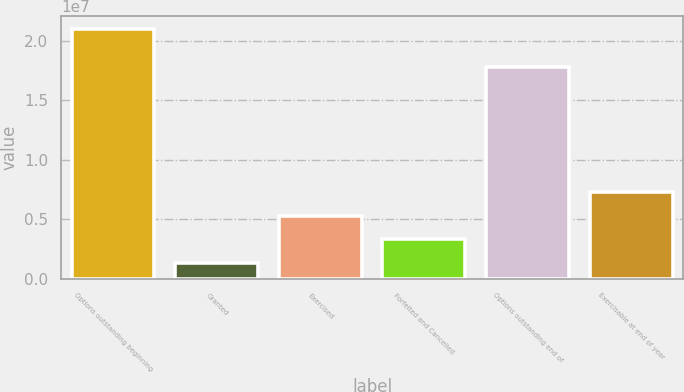<chart> <loc_0><loc_0><loc_500><loc_500><bar_chart><fcel>Options outstanding beginning<fcel>Granted<fcel>Exercised<fcel>Forfeited and Cancelled<fcel>Options outstanding end of<fcel>Exercisable at end of year<nl><fcel>2.10009e+07<fcel>1.3795e+06<fcel>5.30378e+06<fcel>3.34164e+06<fcel>1.78188e+07<fcel>7.26593e+06<nl></chart> 